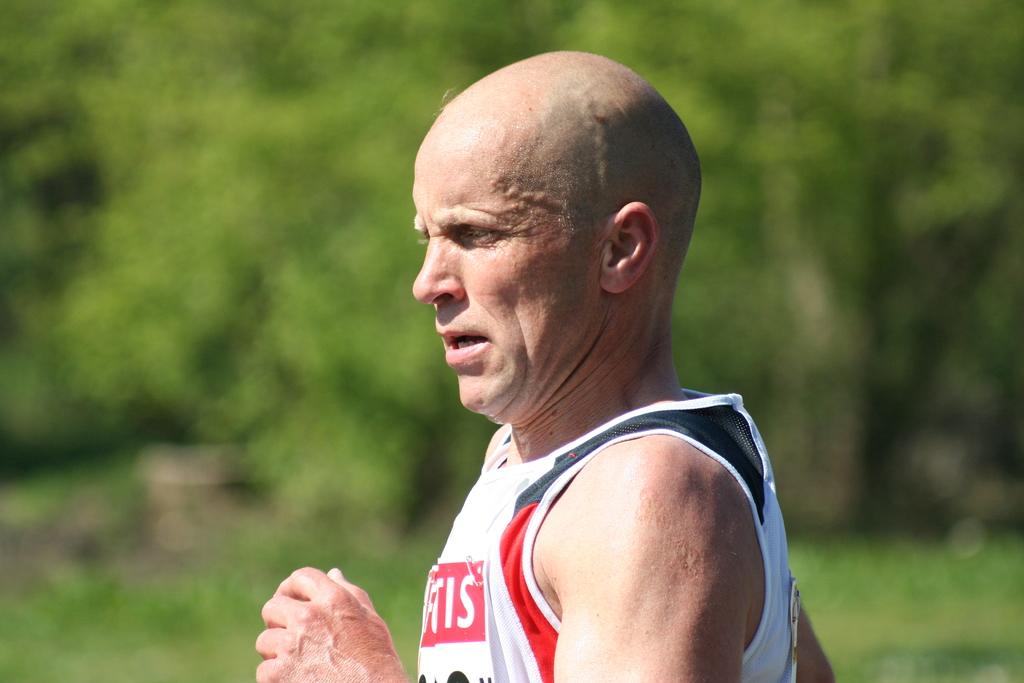What is the last letter on his shirt?
Your answer should be compact. S. Is there a i on his shirt?
Keep it short and to the point. Yes. 